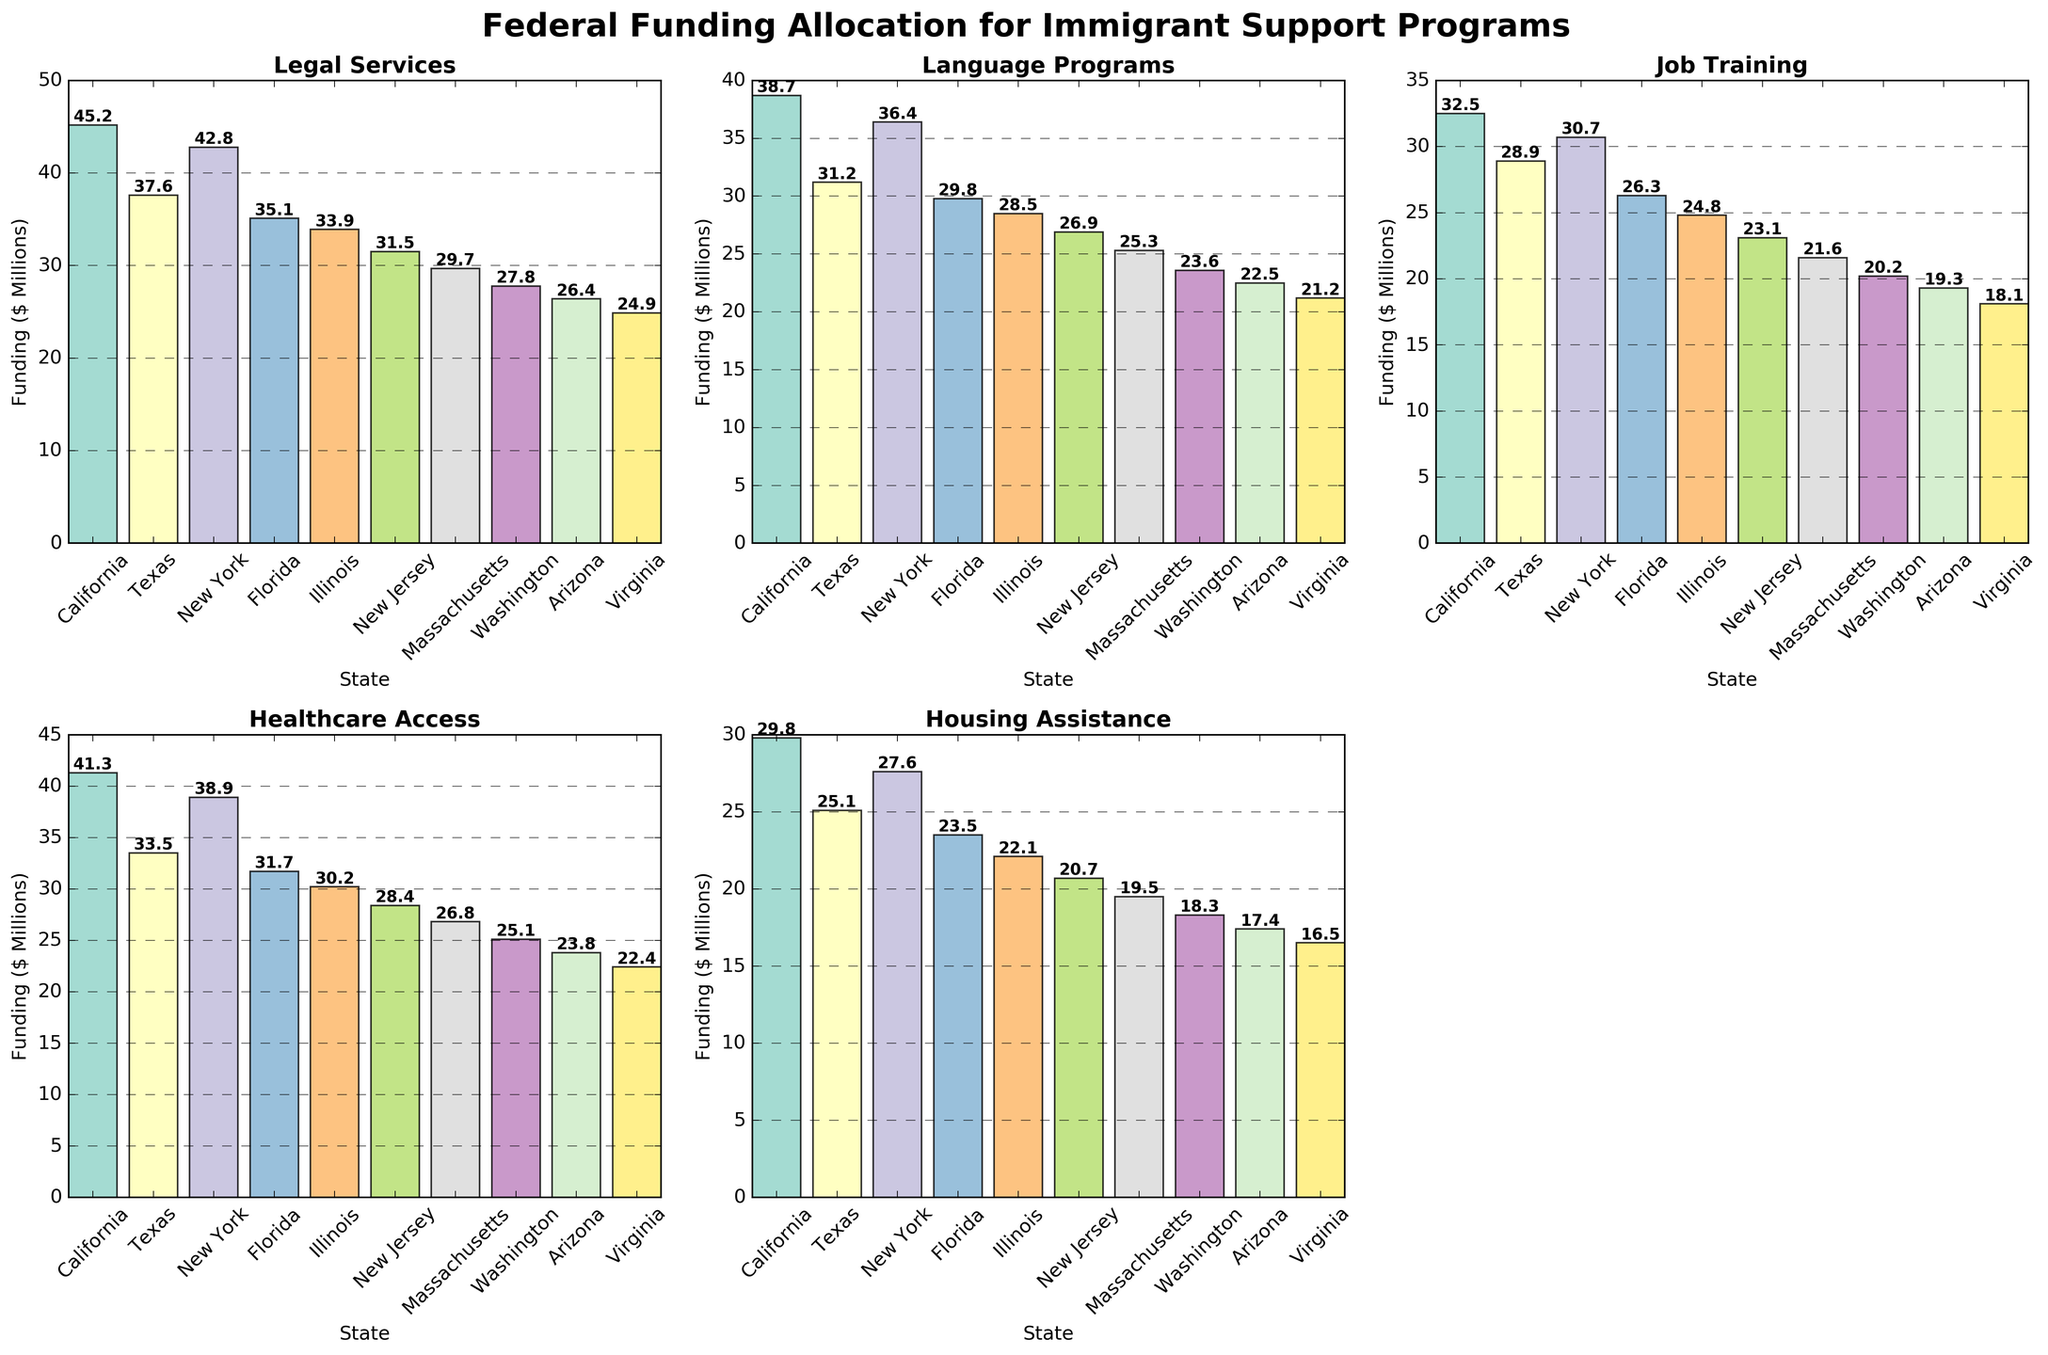Which state allocates the most federal funding for Legal Services? The highest bar in the Legal Services subplot belongs to California.
Answer: California What is the total federal funding allocated to Language Programs by California, Texas, and New York combined? Add the funding values for Language Programs in California (38.7), Texas (31.2), and New York (36.4): 38.7 + 31.2 + 36.4 = 106.3
Answer: 106.3 Compare the funding for Job Training and Healthcare Access in Massachusetts. Which one is higher? Look at the heights of the bars for Job Training (21.6) and Healthcare Access (26.8) in Massachusetts. Since 26.8 is higher than 21.6, Healthcare Access receives more funding.
Answer: Healthcare Access By how much does New York's funding for Housing Assistance exceed that of Virginia? Subtract Virginia's funding for Housing Assistance (16.5) from New York's (27.6): 27.6 - 16.5 = 11.1
Answer: 11.1 What is the average federal funding allocated across all states for Language Programs? Add the funding values for Language Programs across all states (38.7 + 31.2 + 36.4 + 29.8 + 28.5 + 26.9 + 25.3 + 23.6 + 22.5 + 21.2) and divide by the number of states (10): (38.7 + 31.2 + 36.4 + 29.8 + 28.5 + 26.9 + 25.3 + 23.6 + 22.5 + 21.2) / 10 = 28.41
Answer: 28.41 Which state receives the least federal funding for Healthcare Access? The smallest bar in the Healthcare Access subplot belongs to Virginia.
Answer: Virginia 